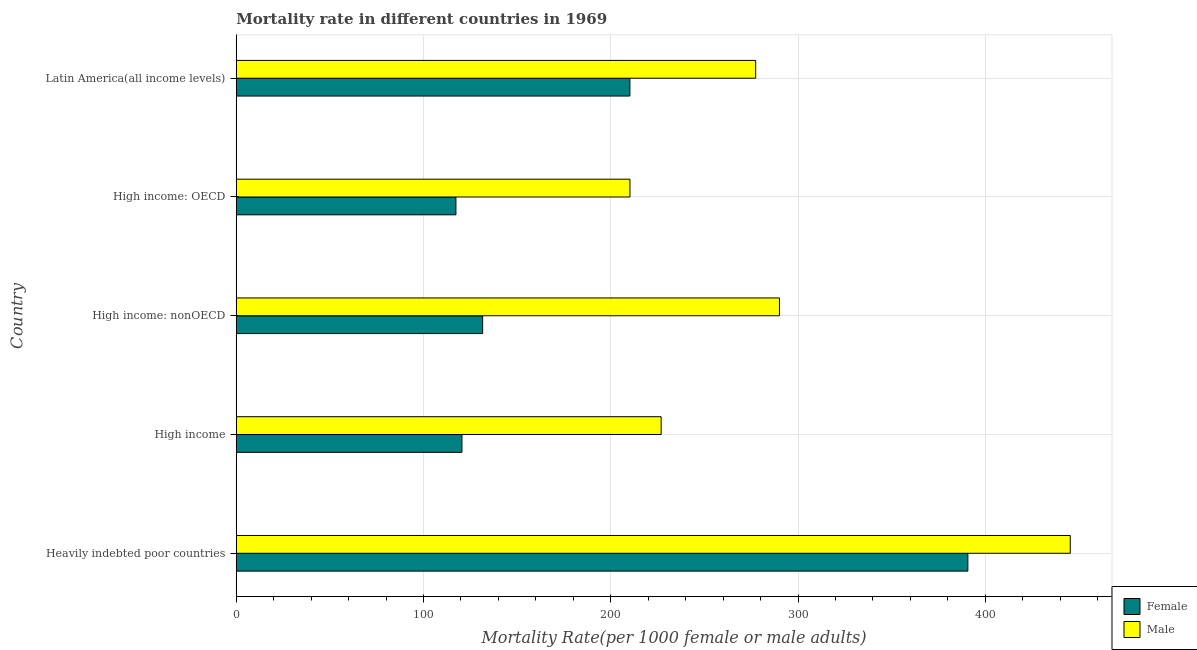How many groups of bars are there?
Provide a succinct answer. 5. How many bars are there on the 3rd tick from the top?
Ensure brevity in your answer.  2. What is the label of the 5th group of bars from the top?
Ensure brevity in your answer.  Heavily indebted poor countries. In how many cases, is the number of bars for a given country not equal to the number of legend labels?
Ensure brevity in your answer.  0. What is the male mortality rate in Heavily indebted poor countries?
Your response must be concise. 445.4. Across all countries, what is the maximum female mortality rate?
Provide a short and direct response. 390.7. Across all countries, what is the minimum female mortality rate?
Provide a succinct answer. 117.31. In which country was the male mortality rate maximum?
Provide a succinct answer. Heavily indebted poor countries. In which country was the female mortality rate minimum?
Ensure brevity in your answer.  High income: OECD. What is the total female mortality rate in the graph?
Your answer should be very brief. 970.34. What is the difference between the male mortality rate in High income and that in High income: OECD?
Provide a succinct answer. 16.66. What is the difference between the male mortality rate in High income and the female mortality rate in High income: OECD?
Make the answer very short. 109.6. What is the average male mortality rate per country?
Keep it short and to the point. 290.01. What is the difference between the male mortality rate and female mortality rate in Latin America(all income levels)?
Your answer should be very brief. 67.16. What is the ratio of the female mortality rate in High income: OECD to that in High income: nonOECD?
Keep it short and to the point. 0.89. What is the difference between the highest and the second highest female mortality rate?
Your response must be concise. 180.47. What is the difference between the highest and the lowest male mortality rate?
Provide a short and direct response. 235.15. What does the 2nd bar from the top in Heavily indebted poor countries represents?
Your answer should be compact. Female. What does the 1st bar from the bottom in Heavily indebted poor countries represents?
Your answer should be very brief. Female. What is the difference between two consecutive major ticks on the X-axis?
Provide a succinct answer. 100. Are the values on the major ticks of X-axis written in scientific E-notation?
Your answer should be compact. No. Does the graph contain any zero values?
Provide a succinct answer. No. How many legend labels are there?
Ensure brevity in your answer.  2. What is the title of the graph?
Offer a very short reply. Mortality rate in different countries in 1969. Does "Total Population" appear as one of the legend labels in the graph?
Your answer should be compact. No. What is the label or title of the X-axis?
Make the answer very short. Mortality Rate(per 1000 female or male adults). What is the Mortality Rate(per 1000 female or male adults) of Female in Heavily indebted poor countries?
Offer a terse response. 390.7. What is the Mortality Rate(per 1000 female or male adults) of Male in Heavily indebted poor countries?
Ensure brevity in your answer.  445.4. What is the Mortality Rate(per 1000 female or male adults) of Female in High income?
Keep it short and to the point. 120.52. What is the Mortality Rate(per 1000 female or male adults) of Male in High income?
Make the answer very short. 226.91. What is the Mortality Rate(per 1000 female or male adults) of Female in High income: nonOECD?
Keep it short and to the point. 131.59. What is the Mortality Rate(per 1000 female or male adults) of Male in High income: nonOECD?
Your answer should be compact. 290.09. What is the Mortality Rate(per 1000 female or male adults) of Female in High income: OECD?
Provide a succinct answer. 117.31. What is the Mortality Rate(per 1000 female or male adults) of Male in High income: OECD?
Make the answer very short. 210.25. What is the Mortality Rate(per 1000 female or male adults) in Female in Latin America(all income levels)?
Offer a very short reply. 210.23. What is the Mortality Rate(per 1000 female or male adults) of Male in Latin America(all income levels)?
Provide a short and direct response. 277.38. Across all countries, what is the maximum Mortality Rate(per 1000 female or male adults) in Female?
Provide a succinct answer. 390.7. Across all countries, what is the maximum Mortality Rate(per 1000 female or male adults) of Male?
Make the answer very short. 445.4. Across all countries, what is the minimum Mortality Rate(per 1000 female or male adults) in Female?
Give a very brief answer. 117.31. Across all countries, what is the minimum Mortality Rate(per 1000 female or male adults) of Male?
Your answer should be compact. 210.25. What is the total Mortality Rate(per 1000 female or male adults) of Female in the graph?
Provide a short and direct response. 970.34. What is the total Mortality Rate(per 1000 female or male adults) of Male in the graph?
Ensure brevity in your answer.  1450.03. What is the difference between the Mortality Rate(per 1000 female or male adults) in Female in Heavily indebted poor countries and that in High income?
Make the answer very short. 270.18. What is the difference between the Mortality Rate(per 1000 female or male adults) in Male in Heavily indebted poor countries and that in High income?
Provide a short and direct response. 218.49. What is the difference between the Mortality Rate(per 1000 female or male adults) in Female in Heavily indebted poor countries and that in High income: nonOECD?
Give a very brief answer. 259.11. What is the difference between the Mortality Rate(per 1000 female or male adults) of Male in Heavily indebted poor countries and that in High income: nonOECD?
Provide a succinct answer. 155.3. What is the difference between the Mortality Rate(per 1000 female or male adults) of Female in Heavily indebted poor countries and that in High income: OECD?
Provide a succinct answer. 273.39. What is the difference between the Mortality Rate(per 1000 female or male adults) of Male in Heavily indebted poor countries and that in High income: OECD?
Make the answer very short. 235.15. What is the difference between the Mortality Rate(per 1000 female or male adults) in Female in Heavily indebted poor countries and that in Latin America(all income levels)?
Keep it short and to the point. 180.47. What is the difference between the Mortality Rate(per 1000 female or male adults) of Male in Heavily indebted poor countries and that in Latin America(all income levels)?
Your response must be concise. 168.01. What is the difference between the Mortality Rate(per 1000 female or male adults) of Female in High income and that in High income: nonOECD?
Ensure brevity in your answer.  -11.07. What is the difference between the Mortality Rate(per 1000 female or male adults) of Male in High income and that in High income: nonOECD?
Ensure brevity in your answer.  -63.18. What is the difference between the Mortality Rate(per 1000 female or male adults) of Female in High income and that in High income: OECD?
Offer a very short reply. 3.21. What is the difference between the Mortality Rate(per 1000 female or male adults) of Male in High income and that in High income: OECD?
Your answer should be compact. 16.66. What is the difference between the Mortality Rate(per 1000 female or male adults) of Female in High income and that in Latin America(all income levels)?
Provide a succinct answer. -89.71. What is the difference between the Mortality Rate(per 1000 female or male adults) in Male in High income and that in Latin America(all income levels)?
Your response must be concise. -50.48. What is the difference between the Mortality Rate(per 1000 female or male adults) of Female in High income: nonOECD and that in High income: OECD?
Offer a terse response. 14.28. What is the difference between the Mortality Rate(per 1000 female or male adults) of Male in High income: nonOECD and that in High income: OECD?
Give a very brief answer. 79.84. What is the difference between the Mortality Rate(per 1000 female or male adults) of Female in High income: nonOECD and that in Latin America(all income levels)?
Make the answer very short. -78.64. What is the difference between the Mortality Rate(per 1000 female or male adults) in Male in High income: nonOECD and that in Latin America(all income levels)?
Offer a very short reply. 12.71. What is the difference between the Mortality Rate(per 1000 female or male adults) in Female in High income: OECD and that in Latin America(all income levels)?
Give a very brief answer. -92.92. What is the difference between the Mortality Rate(per 1000 female or male adults) in Male in High income: OECD and that in Latin America(all income levels)?
Provide a short and direct response. -67.14. What is the difference between the Mortality Rate(per 1000 female or male adults) of Female in Heavily indebted poor countries and the Mortality Rate(per 1000 female or male adults) of Male in High income?
Keep it short and to the point. 163.79. What is the difference between the Mortality Rate(per 1000 female or male adults) of Female in Heavily indebted poor countries and the Mortality Rate(per 1000 female or male adults) of Male in High income: nonOECD?
Provide a short and direct response. 100.61. What is the difference between the Mortality Rate(per 1000 female or male adults) of Female in Heavily indebted poor countries and the Mortality Rate(per 1000 female or male adults) of Male in High income: OECD?
Keep it short and to the point. 180.45. What is the difference between the Mortality Rate(per 1000 female or male adults) in Female in Heavily indebted poor countries and the Mortality Rate(per 1000 female or male adults) in Male in Latin America(all income levels)?
Your response must be concise. 113.31. What is the difference between the Mortality Rate(per 1000 female or male adults) in Female in High income and the Mortality Rate(per 1000 female or male adults) in Male in High income: nonOECD?
Your answer should be very brief. -169.57. What is the difference between the Mortality Rate(per 1000 female or male adults) of Female in High income and the Mortality Rate(per 1000 female or male adults) of Male in High income: OECD?
Your response must be concise. -89.73. What is the difference between the Mortality Rate(per 1000 female or male adults) of Female in High income and the Mortality Rate(per 1000 female or male adults) of Male in Latin America(all income levels)?
Your answer should be very brief. -156.86. What is the difference between the Mortality Rate(per 1000 female or male adults) in Female in High income: nonOECD and the Mortality Rate(per 1000 female or male adults) in Male in High income: OECD?
Provide a succinct answer. -78.66. What is the difference between the Mortality Rate(per 1000 female or male adults) of Female in High income: nonOECD and the Mortality Rate(per 1000 female or male adults) of Male in Latin America(all income levels)?
Ensure brevity in your answer.  -145.8. What is the difference between the Mortality Rate(per 1000 female or male adults) in Female in High income: OECD and the Mortality Rate(per 1000 female or male adults) in Male in Latin America(all income levels)?
Offer a very short reply. -160.08. What is the average Mortality Rate(per 1000 female or male adults) of Female per country?
Keep it short and to the point. 194.07. What is the average Mortality Rate(per 1000 female or male adults) of Male per country?
Your answer should be compact. 290.01. What is the difference between the Mortality Rate(per 1000 female or male adults) in Female and Mortality Rate(per 1000 female or male adults) in Male in Heavily indebted poor countries?
Ensure brevity in your answer.  -54.7. What is the difference between the Mortality Rate(per 1000 female or male adults) in Female and Mortality Rate(per 1000 female or male adults) in Male in High income?
Keep it short and to the point. -106.39. What is the difference between the Mortality Rate(per 1000 female or male adults) in Female and Mortality Rate(per 1000 female or male adults) in Male in High income: nonOECD?
Offer a very short reply. -158.5. What is the difference between the Mortality Rate(per 1000 female or male adults) in Female and Mortality Rate(per 1000 female or male adults) in Male in High income: OECD?
Offer a terse response. -92.94. What is the difference between the Mortality Rate(per 1000 female or male adults) of Female and Mortality Rate(per 1000 female or male adults) of Male in Latin America(all income levels)?
Your response must be concise. -67.16. What is the ratio of the Mortality Rate(per 1000 female or male adults) of Female in Heavily indebted poor countries to that in High income?
Ensure brevity in your answer.  3.24. What is the ratio of the Mortality Rate(per 1000 female or male adults) of Male in Heavily indebted poor countries to that in High income?
Offer a terse response. 1.96. What is the ratio of the Mortality Rate(per 1000 female or male adults) of Female in Heavily indebted poor countries to that in High income: nonOECD?
Provide a short and direct response. 2.97. What is the ratio of the Mortality Rate(per 1000 female or male adults) in Male in Heavily indebted poor countries to that in High income: nonOECD?
Offer a very short reply. 1.54. What is the ratio of the Mortality Rate(per 1000 female or male adults) in Female in Heavily indebted poor countries to that in High income: OECD?
Your answer should be compact. 3.33. What is the ratio of the Mortality Rate(per 1000 female or male adults) in Male in Heavily indebted poor countries to that in High income: OECD?
Give a very brief answer. 2.12. What is the ratio of the Mortality Rate(per 1000 female or male adults) of Female in Heavily indebted poor countries to that in Latin America(all income levels)?
Your response must be concise. 1.86. What is the ratio of the Mortality Rate(per 1000 female or male adults) of Male in Heavily indebted poor countries to that in Latin America(all income levels)?
Ensure brevity in your answer.  1.61. What is the ratio of the Mortality Rate(per 1000 female or male adults) in Female in High income to that in High income: nonOECD?
Offer a terse response. 0.92. What is the ratio of the Mortality Rate(per 1000 female or male adults) of Male in High income to that in High income: nonOECD?
Your response must be concise. 0.78. What is the ratio of the Mortality Rate(per 1000 female or male adults) in Female in High income to that in High income: OECD?
Keep it short and to the point. 1.03. What is the ratio of the Mortality Rate(per 1000 female or male adults) in Male in High income to that in High income: OECD?
Your answer should be very brief. 1.08. What is the ratio of the Mortality Rate(per 1000 female or male adults) of Female in High income to that in Latin America(all income levels)?
Make the answer very short. 0.57. What is the ratio of the Mortality Rate(per 1000 female or male adults) in Male in High income to that in Latin America(all income levels)?
Make the answer very short. 0.82. What is the ratio of the Mortality Rate(per 1000 female or male adults) in Female in High income: nonOECD to that in High income: OECD?
Your answer should be very brief. 1.12. What is the ratio of the Mortality Rate(per 1000 female or male adults) in Male in High income: nonOECD to that in High income: OECD?
Provide a short and direct response. 1.38. What is the ratio of the Mortality Rate(per 1000 female or male adults) of Female in High income: nonOECD to that in Latin America(all income levels)?
Ensure brevity in your answer.  0.63. What is the ratio of the Mortality Rate(per 1000 female or male adults) in Male in High income: nonOECD to that in Latin America(all income levels)?
Offer a terse response. 1.05. What is the ratio of the Mortality Rate(per 1000 female or male adults) of Female in High income: OECD to that in Latin America(all income levels)?
Make the answer very short. 0.56. What is the ratio of the Mortality Rate(per 1000 female or male adults) in Male in High income: OECD to that in Latin America(all income levels)?
Your answer should be compact. 0.76. What is the difference between the highest and the second highest Mortality Rate(per 1000 female or male adults) of Female?
Make the answer very short. 180.47. What is the difference between the highest and the second highest Mortality Rate(per 1000 female or male adults) of Male?
Give a very brief answer. 155.3. What is the difference between the highest and the lowest Mortality Rate(per 1000 female or male adults) in Female?
Your response must be concise. 273.39. What is the difference between the highest and the lowest Mortality Rate(per 1000 female or male adults) of Male?
Give a very brief answer. 235.15. 